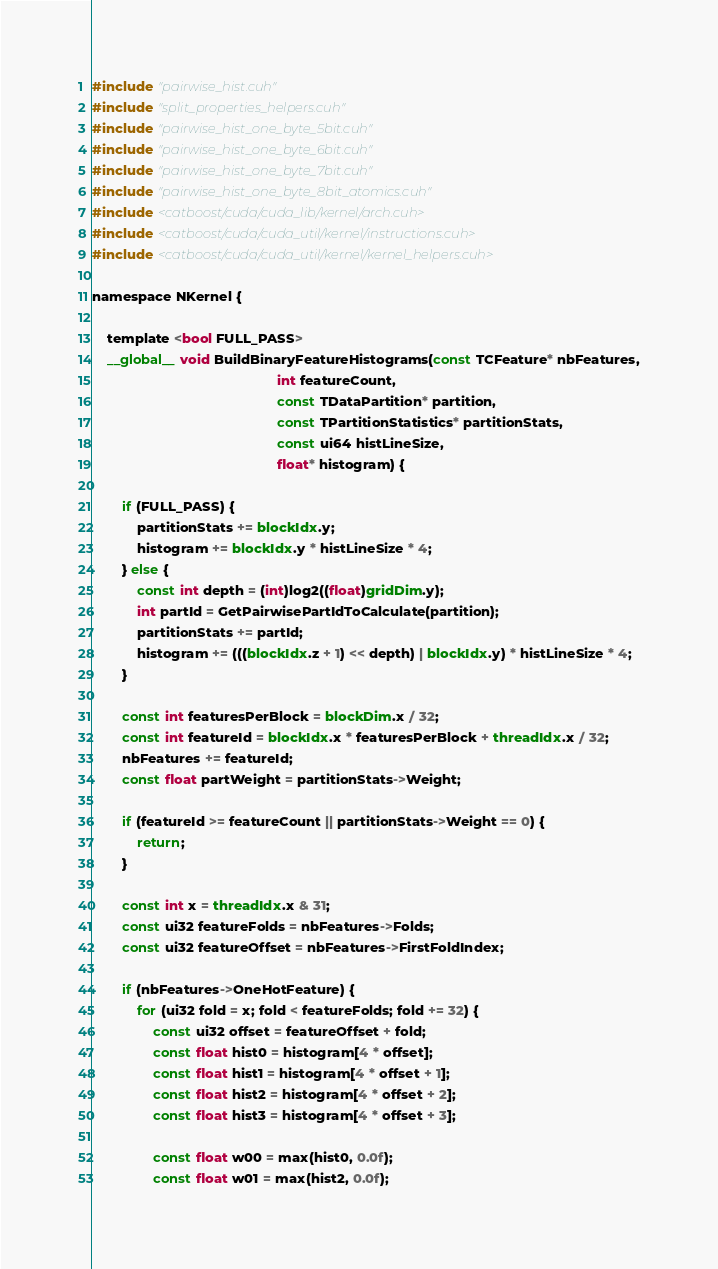<code> <loc_0><loc_0><loc_500><loc_500><_Cuda_>#include "pairwise_hist.cuh"
#include "split_properties_helpers.cuh"
#include "pairwise_hist_one_byte_5bit.cuh"
#include "pairwise_hist_one_byte_6bit.cuh"
#include "pairwise_hist_one_byte_7bit.cuh"
#include "pairwise_hist_one_byte_8bit_atomics.cuh"
#include <catboost/cuda/cuda_lib/kernel/arch.cuh>
#include <catboost/cuda/cuda_util/kernel/instructions.cuh>
#include <catboost/cuda/cuda_util/kernel/kernel_helpers.cuh>

namespace NKernel {

    template <bool FULL_PASS>
    __global__ void BuildBinaryFeatureHistograms(const TCFeature* nbFeatures,
                                                 int featureCount,
                                                 const TDataPartition* partition,
                                                 const TPartitionStatistics* partitionStats,
                                                 const ui64 histLineSize,
                                                 float* histogram) {

        if (FULL_PASS) {
            partitionStats += blockIdx.y;
            histogram += blockIdx.y * histLineSize * 4;
        } else {
            const int depth = (int)log2((float)gridDim.y);
            int partId = GetPairwisePartIdToCalculate(partition);
            partitionStats += partId;
            histogram += (((blockIdx.z + 1) << depth) | blockIdx.y) * histLineSize * 4;
        }

        const int featuresPerBlock = blockDim.x / 32;
        const int featureId = blockIdx.x * featuresPerBlock + threadIdx.x / 32;
        nbFeatures += featureId;
        const float partWeight = partitionStats->Weight;

        if (featureId >= featureCount || partitionStats->Weight == 0) {
            return;
        }

        const int x = threadIdx.x & 31;
        const ui32 featureFolds = nbFeatures->Folds;
        const ui32 featureOffset = nbFeatures->FirstFoldIndex;

        if (nbFeatures->OneHotFeature) {
            for (ui32 fold = x; fold < featureFolds; fold += 32) {
                const ui32 offset = featureOffset + fold;
                const float hist0 = histogram[4 * offset];
                const float hist1 = histogram[4 * offset + 1];
                const float hist2 = histogram[4 * offset + 2];
                const float hist3 = histogram[4 * offset + 3];

                const float w00 = max(hist0, 0.0f);
                const float w01 = max(hist2, 0.0f);</code> 